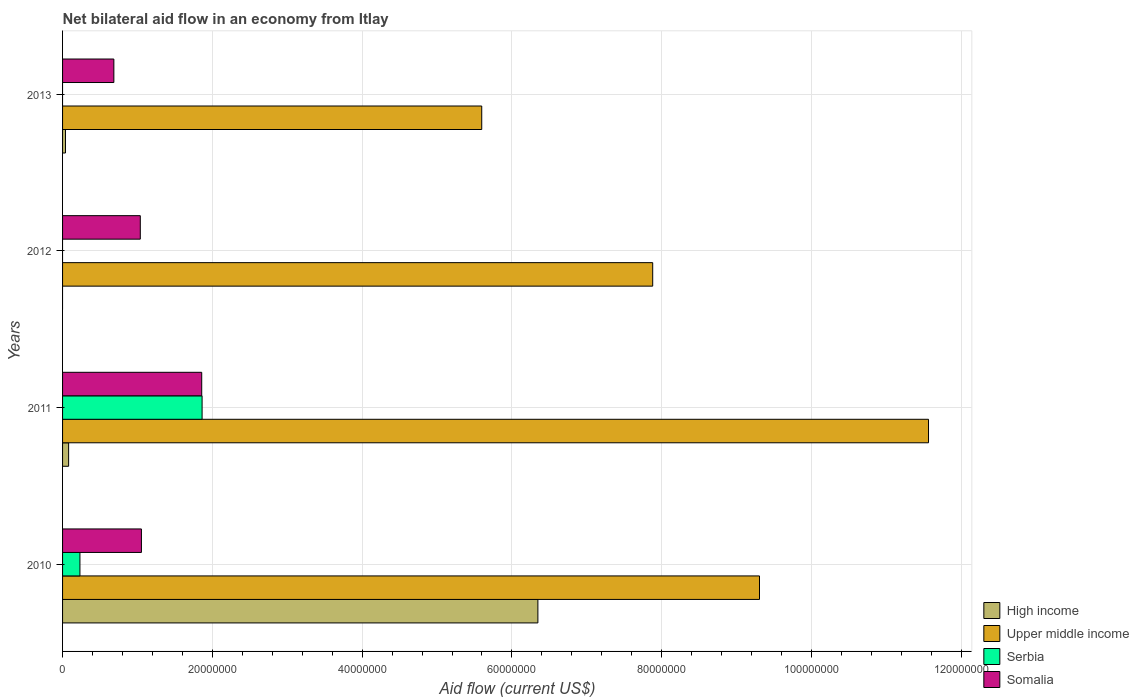Are the number of bars per tick equal to the number of legend labels?
Your answer should be compact. No. Are the number of bars on each tick of the Y-axis equal?
Your response must be concise. No. How many bars are there on the 1st tick from the bottom?
Your answer should be compact. 4. What is the label of the 2nd group of bars from the top?
Provide a short and direct response. 2012. In how many cases, is the number of bars for a given year not equal to the number of legend labels?
Provide a short and direct response. 2. What is the net bilateral aid flow in High income in 2011?
Your answer should be compact. 8.10e+05. Across all years, what is the maximum net bilateral aid flow in Upper middle income?
Your answer should be very brief. 1.16e+08. Across all years, what is the minimum net bilateral aid flow in Somalia?
Your answer should be very brief. 6.85e+06. What is the total net bilateral aid flow in Somalia in the graph?
Keep it short and to the point. 4.63e+07. What is the difference between the net bilateral aid flow in High income in 2011 and that in 2013?
Your answer should be compact. 4.20e+05. What is the difference between the net bilateral aid flow in Serbia in 2013 and the net bilateral aid flow in Somalia in 2012?
Your response must be concise. -1.04e+07. What is the average net bilateral aid flow in Serbia per year?
Provide a succinct answer. 5.24e+06. In the year 2010, what is the difference between the net bilateral aid flow in High income and net bilateral aid flow in Somalia?
Provide a short and direct response. 5.29e+07. In how many years, is the net bilateral aid flow in Upper middle income greater than 100000000 US$?
Ensure brevity in your answer.  1. What is the ratio of the net bilateral aid flow in High income in 2010 to that in 2011?
Offer a terse response. 78.36. What is the difference between the highest and the second highest net bilateral aid flow in High income?
Give a very brief answer. 6.27e+07. What is the difference between the highest and the lowest net bilateral aid flow in Upper middle income?
Make the answer very short. 5.97e+07. In how many years, is the net bilateral aid flow in High income greater than the average net bilateral aid flow in High income taken over all years?
Offer a very short reply. 1. Is it the case that in every year, the sum of the net bilateral aid flow in Serbia and net bilateral aid flow in High income is greater than the sum of net bilateral aid flow in Upper middle income and net bilateral aid flow in Somalia?
Give a very brief answer. No. Is it the case that in every year, the sum of the net bilateral aid flow in Serbia and net bilateral aid flow in Upper middle income is greater than the net bilateral aid flow in High income?
Your response must be concise. Yes. How many bars are there?
Provide a succinct answer. 13. Are all the bars in the graph horizontal?
Your response must be concise. Yes. Does the graph contain any zero values?
Provide a short and direct response. Yes. Does the graph contain grids?
Offer a very short reply. Yes. How many legend labels are there?
Provide a short and direct response. 4. What is the title of the graph?
Ensure brevity in your answer.  Net bilateral aid flow in an economy from Itlay. What is the Aid flow (current US$) of High income in 2010?
Offer a terse response. 6.35e+07. What is the Aid flow (current US$) of Upper middle income in 2010?
Your answer should be compact. 9.31e+07. What is the Aid flow (current US$) of Serbia in 2010?
Keep it short and to the point. 2.32e+06. What is the Aid flow (current US$) of Somalia in 2010?
Your answer should be very brief. 1.05e+07. What is the Aid flow (current US$) of High income in 2011?
Your response must be concise. 8.10e+05. What is the Aid flow (current US$) of Upper middle income in 2011?
Give a very brief answer. 1.16e+08. What is the Aid flow (current US$) in Serbia in 2011?
Your response must be concise. 1.86e+07. What is the Aid flow (current US$) of Somalia in 2011?
Offer a very short reply. 1.86e+07. What is the Aid flow (current US$) in High income in 2012?
Provide a short and direct response. 0. What is the Aid flow (current US$) of Upper middle income in 2012?
Make the answer very short. 7.88e+07. What is the Aid flow (current US$) in Serbia in 2012?
Offer a very short reply. 0. What is the Aid flow (current US$) in Somalia in 2012?
Your answer should be compact. 1.04e+07. What is the Aid flow (current US$) in High income in 2013?
Make the answer very short. 3.90e+05. What is the Aid flow (current US$) in Upper middle income in 2013?
Make the answer very short. 5.60e+07. What is the Aid flow (current US$) of Somalia in 2013?
Ensure brevity in your answer.  6.85e+06. Across all years, what is the maximum Aid flow (current US$) of High income?
Provide a short and direct response. 6.35e+07. Across all years, what is the maximum Aid flow (current US$) in Upper middle income?
Give a very brief answer. 1.16e+08. Across all years, what is the maximum Aid flow (current US$) of Serbia?
Offer a very short reply. 1.86e+07. Across all years, what is the maximum Aid flow (current US$) in Somalia?
Ensure brevity in your answer.  1.86e+07. Across all years, what is the minimum Aid flow (current US$) of Upper middle income?
Ensure brevity in your answer.  5.60e+07. Across all years, what is the minimum Aid flow (current US$) in Somalia?
Give a very brief answer. 6.85e+06. What is the total Aid flow (current US$) in High income in the graph?
Your answer should be very brief. 6.47e+07. What is the total Aid flow (current US$) in Upper middle income in the graph?
Your answer should be compact. 3.43e+08. What is the total Aid flow (current US$) in Serbia in the graph?
Give a very brief answer. 2.10e+07. What is the total Aid flow (current US$) of Somalia in the graph?
Offer a terse response. 4.63e+07. What is the difference between the Aid flow (current US$) in High income in 2010 and that in 2011?
Offer a very short reply. 6.27e+07. What is the difference between the Aid flow (current US$) of Upper middle income in 2010 and that in 2011?
Your answer should be compact. -2.26e+07. What is the difference between the Aid flow (current US$) in Serbia in 2010 and that in 2011?
Keep it short and to the point. -1.63e+07. What is the difference between the Aid flow (current US$) of Somalia in 2010 and that in 2011?
Give a very brief answer. -8.05e+06. What is the difference between the Aid flow (current US$) of Upper middle income in 2010 and that in 2012?
Ensure brevity in your answer.  1.43e+07. What is the difference between the Aid flow (current US$) of High income in 2010 and that in 2013?
Your answer should be very brief. 6.31e+07. What is the difference between the Aid flow (current US$) of Upper middle income in 2010 and that in 2013?
Keep it short and to the point. 3.71e+07. What is the difference between the Aid flow (current US$) in Somalia in 2010 and that in 2013?
Offer a very short reply. 3.68e+06. What is the difference between the Aid flow (current US$) in Upper middle income in 2011 and that in 2012?
Offer a very short reply. 3.68e+07. What is the difference between the Aid flow (current US$) in Somalia in 2011 and that in 2012?
Your answer should be very brief. 8.20e+06. What is the difference between the Aid flow (current US$) of High income in 2011 and that in 2013?
Offer a terse response. 4.20e+05. What is the difference between the Aid flow (current US$) of Upper middle income in 2011 and that in 2013?
Your answer should be compact. 5.97e+07. What is the difference between the Aid flow (current US$) of Somalia in 2011 and that in 2013?
Your answer should be compact. 1.17e+07. What is the difference between the Aid flow (current US$) in Upper middle income in 2012 and that in 2013?
Provide a succinct answer. 2.28e+07. What is the difference between the Aid flow (current US$) in Somalia in 2012 and that in 2013?
Make the answer very short. 3.53e+06. What is the difference between the Aid flow (current US$) in High income in 2010 and the Aid flow (current US$) in Upper middle income in 2011?
Keep it short and to the point. -5.22e+07. What is the difference between the Aid flow (current US$) of High income in 2010 and the Aid flow (current US$) of Serbia in 2011?
Offer a very short reply. 4.48e+07. What is the difference between the Aid flow (current US$) of High income in 2010 and the Aid flow (current US$) of Somalia in 2011?
Your answer should be very brief. 4.49e+07. What is the difference between the Aid flow (current US$) of Upper middle income in 2010 and the Aid flow (current US$) of Serbia in 2011?
Ensure brevity in your answer.  7.44e+07. What is the difference between the Aid flow (current US$) of Upper middle income in 2010 and the Aid flow (current US$) of Somalia in 2011?
Provide a short and direct response. 7.45e+07. What is the difference between the Aid flow (current US$) of Serbia in 2010 and the Aid flow (current US$) of Somalia in 2011?
Ensure brevity in your answer.  -1.63e+07. What is the difference between the Aid flow (current US$) of High income in 2010 and the Aid flow (current US$) of Upper middle income in 2012?
Ensure brevity in your answer.  -1.53e+07. What is the difference between the Aid flow (current US$) in High income in 2010 and the Aid flow (current US$) in Somalia in 2012?
Make the answer very short. 5.31e+07. What is the difference between the Aid flow (current US$) in Upper middle income in 2010 and the Aid flow (current US$) in Somalia in 2012?
Make the answer very short. 8.27e+07. What is the difference between the Aid flow (current US$) of Serbia in 2010 and the Aid flow (current US$) of Somalia in 2012?
Provide a succinct answer. -8.06e+06. What is the difference between the Aid flow (current US$) in High income in 2010 and the Aid flow (current US$) in Upper middle income in 2013?
Your response must be concise. 7.50e+06. What is the difference between the Aid flow (current US$) in High income in 2010 and the Aid flow (current US$) in Somalia in 2013?
Give a very brief answer. 5.66e+07. What is the difference between the Aid flow (current US$) of Upper middle income in 2010 and the Aid flow (current US$) of Somalia in 2013?
Make the answer very short. 8.62e+07. What is the difference between the Aid flow (current US$) of Serbia in 2010 and the Aid flow (current US$) of Somalia in 2013?
Keep it short and to the point. -4.53e+06. What is the difference between the Aid flow (current US$) in High income in 2011 and the Aid flow (current US$) in Upper middle income in 2012?
Make the answer very short. -7.80e+07. What is the difference between the Aid flow (current US$) of High income in 2011 and the Aid flow (current US$) of Somalia in 2012?
Your response must be concise. -9.57e+06. What is the difference between the Aid flow (current US$) of Upper middle income in 2011 and the Aid flow (current US$) of Somalia in 2012?
Make the answer very short. 1.05e+08. What is the difference between the Aid flow (current US$) in Serbia in 2011 and the Aid flow (current US$) in Somalia in 2012?
Give a very brief answer. 8.25e+06. What is the difference between the Aid flow (current US$) of High income in 2011 and the Aid flow (current US$) of Upper middle income in 2013?
Keep it short and to the point. -5.52e+07. What is the difference between the Aid flow (current US$) of High income in 2011 and the Aid flow (current US$) of Somalia in 2013?
Keep it short and to the point. -6.04e+06. What is the difference between the Aid flow (current US$) in Upper middle income in 2011 and the Aid flow (current US$) in Somalia in 2013?
Keep it short and to the point. 1.09e+08. What is the difference between the Aid flow (current US$) in Serbia in 2011 and the Aid flow (current US$) in Somalia in 2013?
Ensure brevity in your answer.  1.18e+07. What is the difference between the Aid flow (current US$) in Upper middle income in 2012 and the Aid flow (current US$) in Somalia in 2013?
Give a very brief answer. 7.20e+07. What is the average Aid flow (current US$) in High income per year?
Keep it short and to the point. 1.62e+07. What is the average Aid flow (current US$) in Upper middle income per year?
Offer a very short reply. 8.59e+07. What is the average Aid flow (current US$) of Serbia per year?
Keep it short and to the point. 5.24e+06. What is the average Aid flow (current US$) of Somalia per year?
Your response must be concise. 1.16e+07. In the year 2010, what is the difference between the Aid flow (current US$) in High income and Aid flow (current US$) in Upper middle income?
Give a very brief answer. -2.96e+07. In the year 2010, what is the difference between the Aid flow (current US$) of High income and Aid flow (current US$) of Serbia?
Your response must be concise. 6.12e+07. In the year 2010, what is the difference between the Aid flow (current US$) of High income and Aid flow (current US$) of Somalia?
Ensure brevity in your answer.  5.29e+07. In the year 2010, what is the difference between the Aid flow (current US$) of Upper middle income and Aid flow (current US$) of Serbia?
Provide a short and direct response. 9.07e+07. In the year 2010, what is the difference between the Aid flow (current US$) in Upper middle income and Aid flow (current US$) in Somalia?
Your answer should be very brief. 8.25e+07. In the year 2010, what is the difference between the Aid flow (current US$) in Serbia and Aid flow (current US$) in Somalia?
Your response must be concise. -8.21e+06. In the year 2011, what is the difference between the Aid flow (current US$) in High income and Aid flow (current US$) in Upper middle income?
Make the answer very short. -1.15e+08. In the year 2011, what is the difference between the Aid flow (current US$) of High income and Aid flow (current US$) of Serbia?
Your answer should be compact. -1.78e+07. In the year 2011, what is the difference between the Aid flow (current US$) of High income and Aid flow (current US$) of Somalia?
Ensure brevity in your answer.  -1.78e+07. In the year 2011, what is the difference between the Aid flow (current US$) in Upper middle income and Aid flow (current US$) in Serbia?
Offer a very short reply. 9.70e+07. In the year 2011, what is the difference between the Aid flow (current US$) in Upper middle income and Aid flow (current US$) in Somalia?
Provide a succinct answer. 9.70e+07. In the year 2012, what is the difference between the Aid flow (current US$) in Upper middle income and Aid flow (current US$) in Somalia?
Your answer should be very brief. 6.84e+07. In the year 2013, what is the difference between the Aid flow (current US$) in High income and Aid flow (current US$) in Upper middle income?
Offer a terse response. -5.56e+07. In the year 2013, what is the difference between the Aid flow (current US$) of High income and Aid flow (current US$) of Somalia?
Your answer should be compact. -6.46e+06. In the year 2013, what is the difference between the Aid flow (current US$) of Upper middle income and Aid flow (current US$) of Somalia?
Give a very brief answer. 4.91e+07. What is the ratio of the Aid flow (current US$) of High income in 2010 to that in 2011?
Keep it short and to the point. 78.36. What is the ratio of the Aid flow (current US$) in Upper middle income in 2010 to that in 2011?
Give a very brief answer. 0.8. What is the ratio of the Aid flow (current US$) of Serbia in 2010 to that in 2011?
Ensure brevity in your answer.  0.12. What is the ratio of the Aid flow (current US$) of Somalia in 2010 to that in 2011?
Offer a very short reply. 0.57. What is the ratio of the Aid flow (current US$) in Upper middle income in 2010 to that in 2012?
Provide a succinct answer. 1.18. What is the ratio of the Aid flow (current US$) of Somalia in 2010 to that in 2012?
Provide a short and direct response. 1.01. What is the ratio of the Aid flow (current US$) in High income in 2010 to that in 2013?
Keep it short and to the point. 162.74. What is the ratio of the Aid flow (current US$) in Upper middle income in 2010 to that in 2013?
Offer a terse response. 1.66. What is the ratio of the Aid flow (current US$) of Somalia in 2010 to that in 2013?
Offer a terse response. 1.54. What is the ratio of the Aid flow (current US$) of Upper middle income in 2011 to that in 2012?
Make the answer very short. 1.47. What is the ratio of the Aid flow (current US$) of Somalia in 2011 to that in 2012?
Ensure brevity in your answer.  1.79. What is the ratio of the Aid flow (current US$) in High income in 2011 to that in 2013?
Make the answer very short. 2.08. What is the ratio of the Aid flow (current US$) of Upper middle income in 2011 to that in 2013?
Ensure brevity in your answer.  2.07. What is the ratio of the Aid flow (current US$) in Somalia in 2011 to that in 2013?
Your response must be concise. 2.71. What is the ratio of the Aid flow (current US$) in Upper middle income in 2012 to that in 2013?
Offer a very short reply. 1.41. What is the ratio of the Aid flow (current US$) in Somalia in 2012 to that in 2013?
Give a very brief answer. 1.52. What is the difference between the highest and the second highest Aid flow (current US$) of High income?
Your answer should be very brief. 6.27e+07. What is the difference between the highest and the second highest Aid flow (current US$) of Upper middle income?
Provide a succinct answer. 2.26e+07. What is the difference between the highest and the second highest Aid flow (current US$) in Somalia?
Make the answer very short. 8.05e+06. What is the difference between the highest and the lowest Aid flow (current US$) of High income?
Give a very brief answer. 6.35e+07. What is the difference between the highest and the lowest Aid flow (current US$) in Upper middle income?
Your response must be concise. 5.97e+07. What is the difference between the highest and the lowest Aid flow (current US$) in Serbia?
Keep it short and to the point. 1.86e+07. What is the difference between the highest and the lowest Aid flow (current US$) in Somalia?
Offer a very short reply. 1.17e+07. 